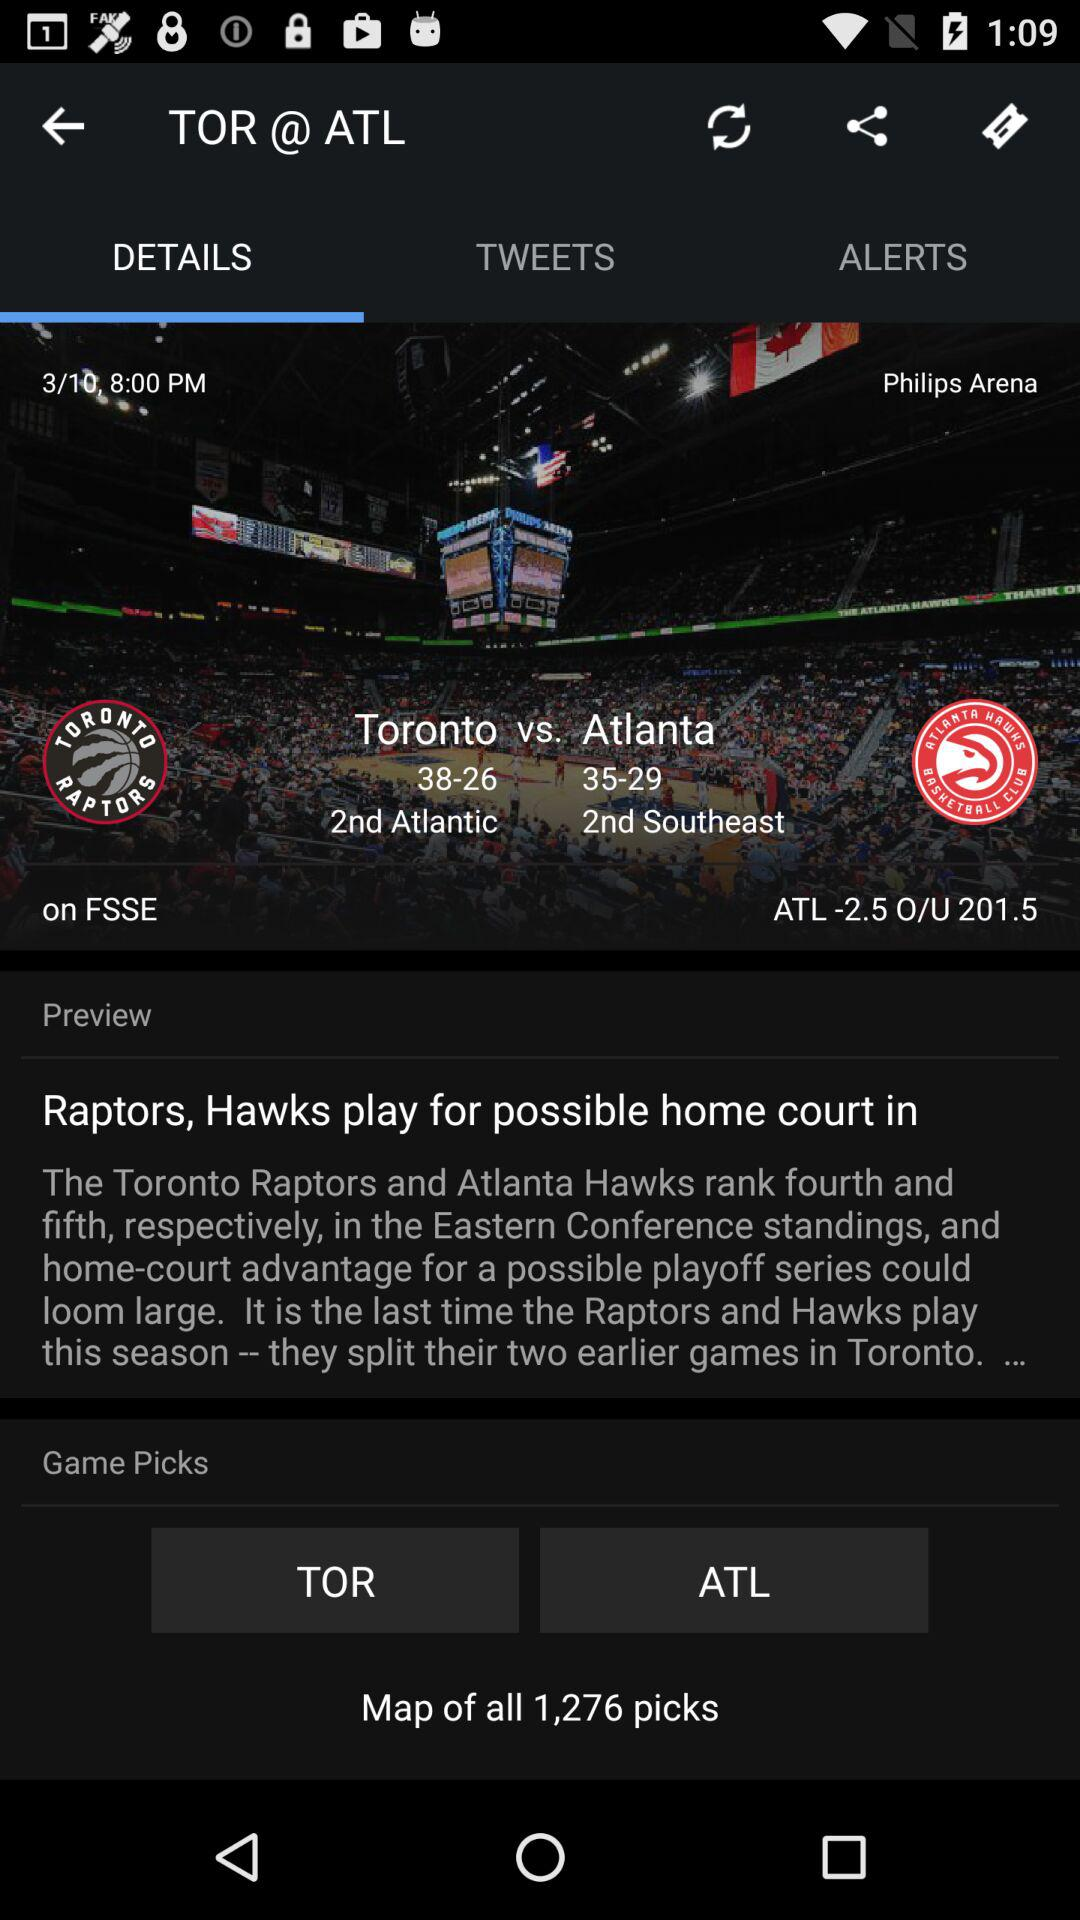Which tab is selected? The selected tab is "DETAILS". 